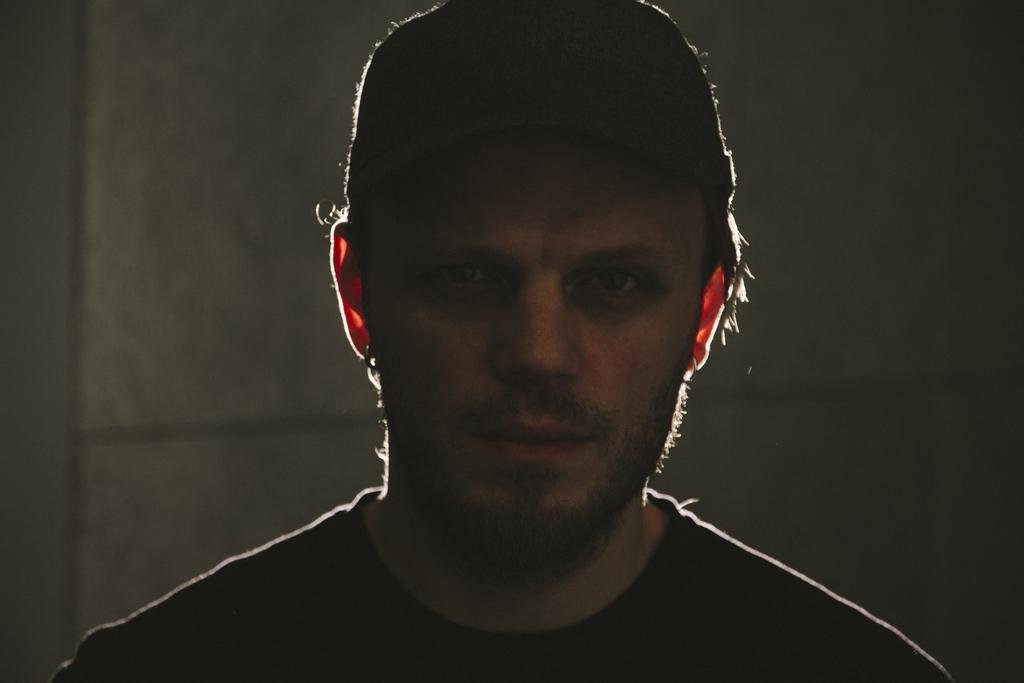Please provide a concise description of this image. In the image there is a man and only the head of the man is visible, the background of him is blur. 